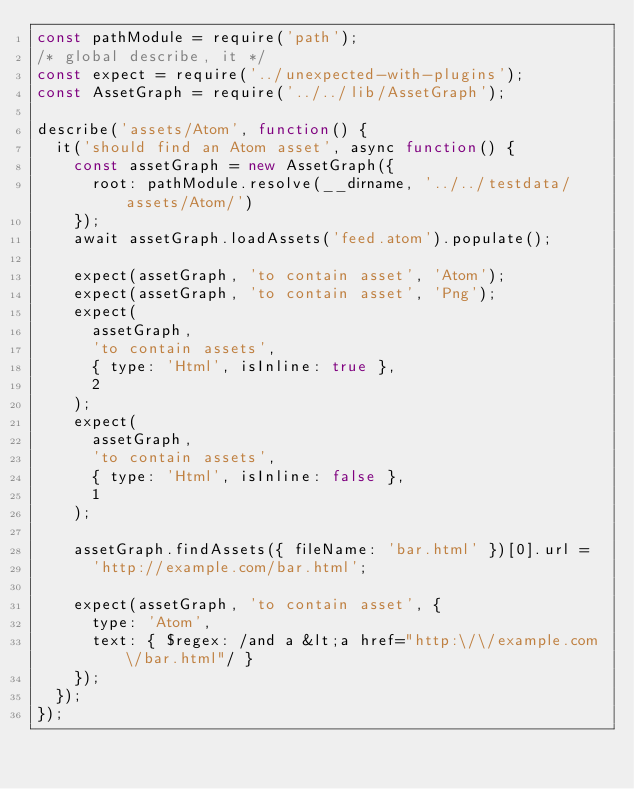Convert code to text. <code><loc_0><loc_0><loc_500><loc_500><_JavaScript_>const pathModule = require('path');
/* global describe, it */
const expect = require('../unexpected-with-plugins');
const AssetGraph = require('../../lib/AssetGraph');

describe('assets/Atom', function() {
  it('should find an Atom asset', async function() {
    const assetGraph = new AssetGraph({
      root: pathModule.resolve(__dirname, '../../testdata/assets/Atom/')
    });
    await assetGraph.loadAssets('feed.atom').populate();

    expect(assetGraph, 'to contain asset', 'Atom');
    expect(assetGraph, 'to contain asset', 'Png');
    expect(
      assetGraph,
      'to contain assets',
      { type: 'Html', isInline: true },
      2
    );
    expect(
      assetGraph,
      'to contain assets',
      { type: 'Html', isInline: false },
      1
    );

    assetGraph.findAssets({ fileName: 'bar.html' })[0].url =
      'http://example.com/bar.html';

    expect(assetGraph, 'to contain asset', {
      type: 'Atom',
      text: { $regex: /and a &lt;a href="http:\/\/example.com\/bar.html"/ }
    });
  });
});
</code> 